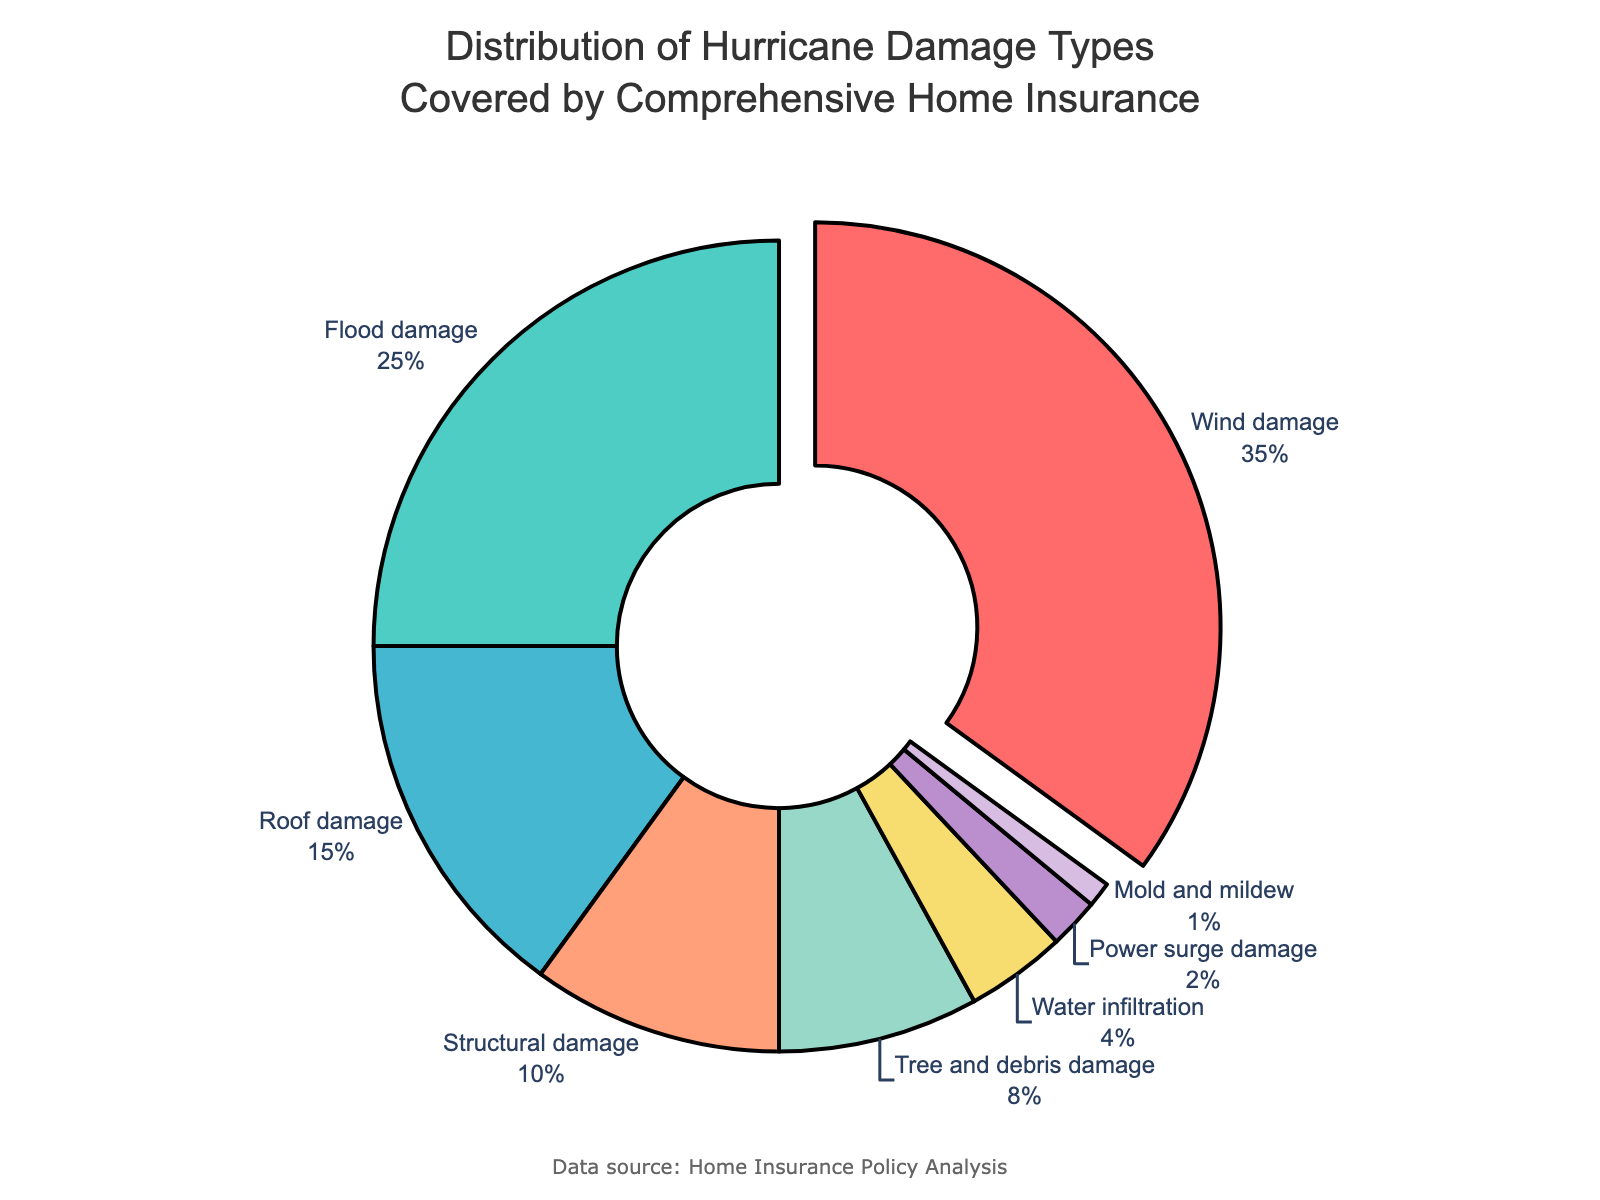What is the most common type of hurricane damage covered by insurance? By looking at the pie chart, the largest segment represents wind damage with the highest percentage.
Answer: Wind damage Which type of damage occupies a larger percentage: flood damage or roof damage? Observing the pie chart, flood damage takes up 25% while roof damage accounts for 15%. Therefore, flood damage occupies a larger percentage.
Answer: Flood damage How many types of damage account for less than 10% each? The pie chart shows the following categories below 10%: structural damage (10%), tree and debris damage (8%), water infiltration (4%), power surge damage (2%), and mold and mildew (1%). Counting these, we have 5 types of damage under 10%.
Answer: 5 What is the combined percentage of tree and debris damage and water infiltration damage? Adding the percentages for tree and debris damage (8%) and water infiltration damage (4%) from the pie chart gives 8% + 4% = 12%.
Answer: 12% Which damage type has the smallest representation in the pie chart? The smallest segment of the pie chart corresponds to mold and mildew damage with 1%.
Answer: Mold and mildew How does the percentage of roof damage compare to the percentage of structural damage? Roof damage accounts for 15%, whereas structural damage accounts for 10%. Therefore, roof damage is 5% higher than structural damage.
Answer: Roof damage is 5% higher Visually, which type of damage appears to be the second most common and what is its percentage? The pie chart shows that flood damage is the second largest segment, comprising 25% of the total.
Answer: Flood damage, 25% If you combine wind damage and flood damage, what percentage of the total does this represent? Adding wind damage (35%) and flood damage (25%) results in 35% + 25% = 60%.
Answer: 60% Which segment is highlighted or pulled out in the pie chart and why? The pie chart highlights the wind damage segment by pulling it out slightly, likely because it represents the largest percentage.
Answer: Wind damage What is the difference between the percentage of wind damage and the percentage of tree and debris damage? Wind damage is 35%, and tree and debris damage is 8%. The difference is 35% - 8% = 27%.
Answer: 27% 